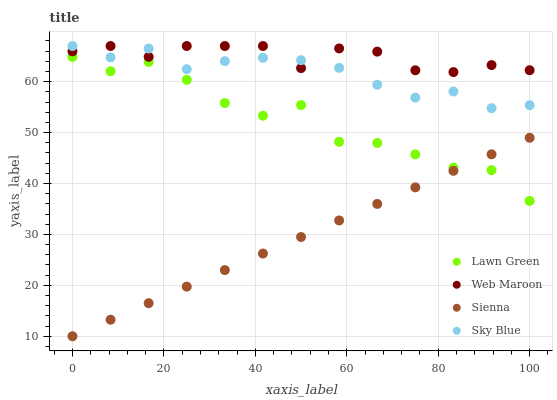Does Sienna have the minimum area under the curve?
Answer yes or no. Yes. Does Web Maroon have the maximum area under the curve?
Answer yes or no. Yes. Does Lawn Green have the minimum area under the curve?
Answer yes or no. No. Does Lawn Green have the maximum area under the curve?
Answer yes or no. No. Is Sienna the smoothest?
Answer yes or no. Yes. Is Lawn Green the roughest?
Answer yes or no. Yes. Is Web Maroon the smoothest?
Answer yes or no. No. Is Web Maroon the roughest?
Answer yes or no. No. Does Sienna have the lowest value?
Answer yes or no. Yes. Does Lawn Green have the lowest value?
Answer yes or no. No. Does Sky Blue have the highest value?
Answer yes or no. Yes. Does Lawn Green have the highest value?
Answer yes or no. No. Is Sienna less than Sky Blue?
Answer yes or no. Yes. Is Sky Blue greater than Sienna?
Answer yes or no. Yes. Does Sienna intersect Lawn Green?
Answer yes or no. Yes. Is Sienna less than Lawn Green?
Answer yes or no. No. Is Sienna greater than Lawn Green?
Answer yes or no. No. Does Sienna intersect Sky Blue?
Answer yes or no. No. 